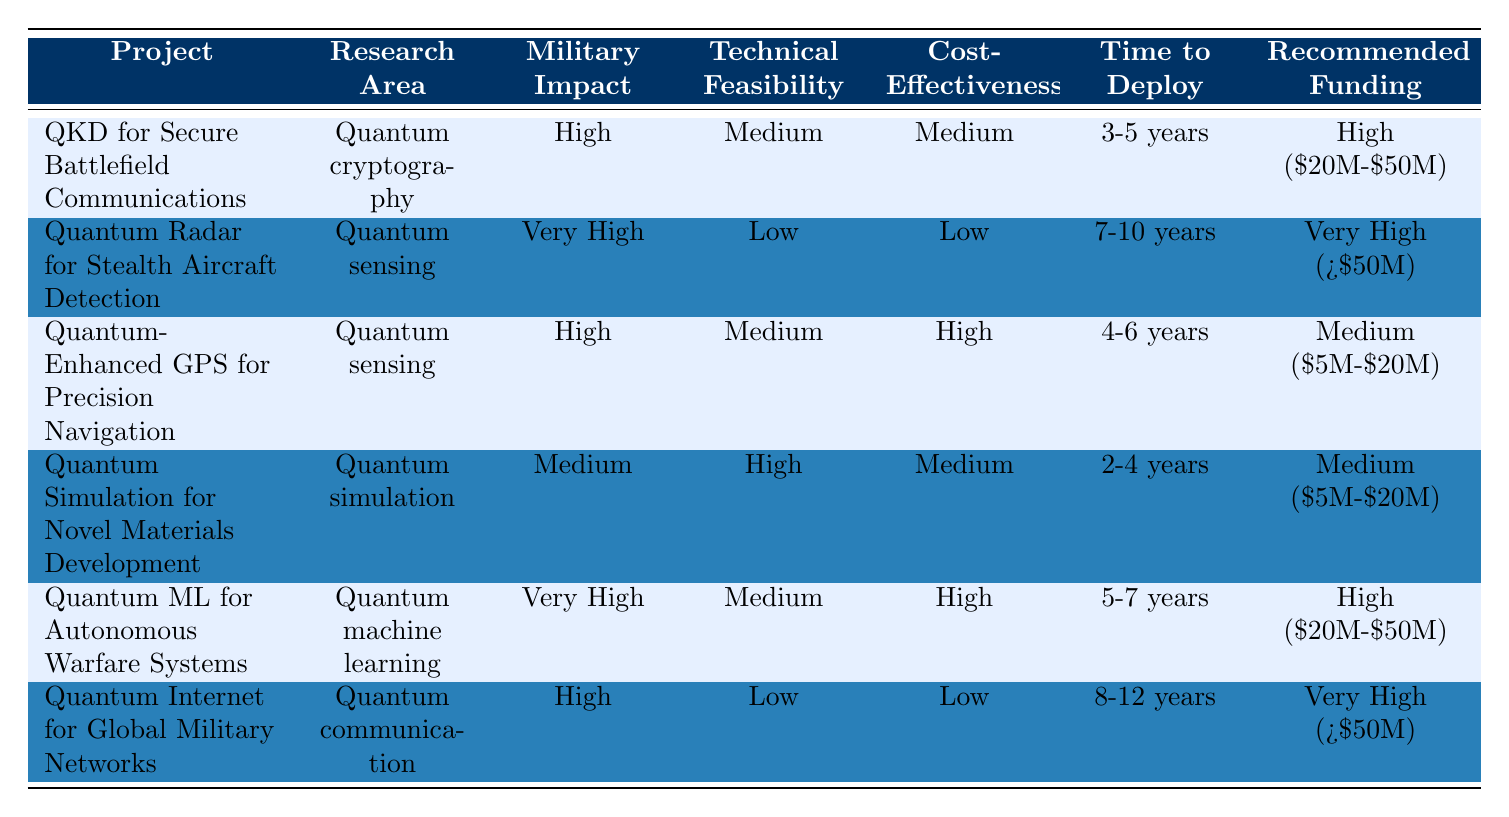What is the recommended funding for the project "QKD for Secure Battlefield Communications"? The table indicates that the recommended funding for "QKD for Secure Battlefield Communications" is categorized as High ($20M-$50M).
Answer: High ($20M-$50M) Which research area has the highest military impact? The project "Quantum Radar for Stealth Aircraft Detection" is in the research area of Quantum sensing and has the highest military impact, rated as Very High.
Answer: Quantum sensing How many projects have a medium technical feasibility rating? The projects "QKD for Secure Battlefield Communications," "Quantum-Enhanced GPS for Precision Navigation," "Quantum Simulation for Novel Materials Development," and "Quantum ML for Autonomous Warfare Systems" have a medium technical feasibility rating, totaling four projects.
Answer: 4 Is the project "Quantum Internet for Global Military Networks" cost-effective? The table lists the cost-effectiveness of this project as Low, which indicates it is not considered cost-effective.
Answer: No Among the projects with very high military impact, what is the range of recommended funding? The "Quantum Radar for Stealth Aircraft Detection" has a recommended funding of Very High (>$50M), and "Quantum ML for Autonomous Warfare Systems" has a recommended funding of High ($20M-$50M). Thus, for projects with very high military impact, the range of recommended funding includes amounts greater than $50M.
Answer: >$50M What is the average time to deployment for projects in the Quantum sensing area? The projects "Quantum Radar for Stealth Aircraft Detection" has a deployment time of 7-10 years and "Quantum-Enhanced GPS for Precision Navigation" has a time of 4-6 years. To find the average, we can calculate the average of their midpoints: (8.5 + 5) / 2 = 6.75 years.
Answer: 6.75 years Is any project categorized with low technical feasibility? Yes, the projects "Quantum Radar for Stealth Aircraft Detection" and "Quantum Internet for Global Military Networks" are both categorized with low technical feasibility.
Answer: Yes What is the total number of projects with high potential military impact? The projects "QKD for Secure Battlefield Communications," "Quantum-Enhanced GPS for Precision Navigation," "Quantum ML for Autonomous Warfare Systems," and "Quantum Internet for Global Military Networks" have high potential military impact, totaling four projects.
Answer: 4 Which project has the longest time to deployment? The project "Quantum Internet for Global Military Networks" has the longest time to deployment, listed as 8-12 years.
Answer: 8-12 years 